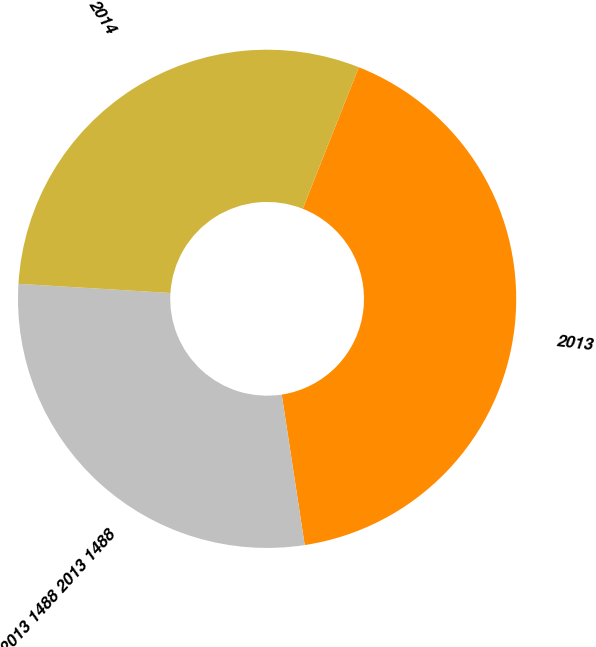Convert chart to OTSL. <chart><loc_0><loc_0><loc_500><loc_500><pie_chart><fcel>2013<fcel>2013 1488 2013 1488<fcel>2014<nl><fcel>41.59%<fcel>28.37%<fcel>30.04%<nl></chart> 